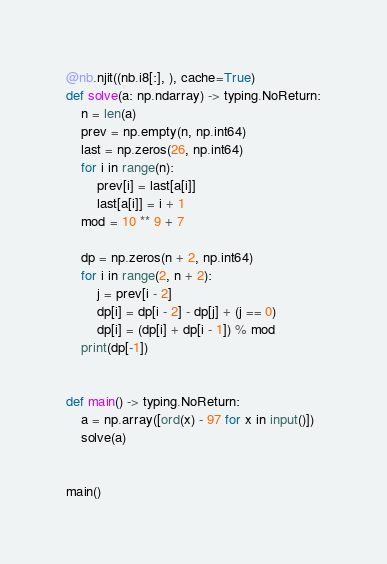Convert code to text. <code><loc_0><loc_0><loc_500><loc_500><_Python_>
@nb.njit((nb.i8[:], ), cache=True)
def solve(a: np.ndarray) -> typing.NoReturn:
    n = len(a)
    prev = np.empty(n, np.int64)
    last = np.zeros(26, np.int64)
    for i in range(n):
        prev[i] = last[a[i]]
        last[a[i]] = i + 1
    mod = 10 ** 9 + 7

    dp = np.zeros(n + 2, np.int64)
    for i in range(2, n + 2):
        j = prev[i - 2]
        dp[i] = dp[i - 2] - dp[j] + (j == 0)
        dp[i] = (dp[i] + dp[i - 1]) % mod
    print(dp[-1])


def main() -> typing.NoReturn:
    a = np.array([ord(x) - 97 for x in input()])
    solve(a)


main()
</code> 